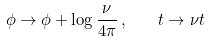Convert formula to latex. <formula><loc_0><loc_0><loc_500><loc_500>\phi \rightarrow \phi + \log \frac { \nu } { 4 \pi } \, , \quad t \rightarrow \nu t</formula> 